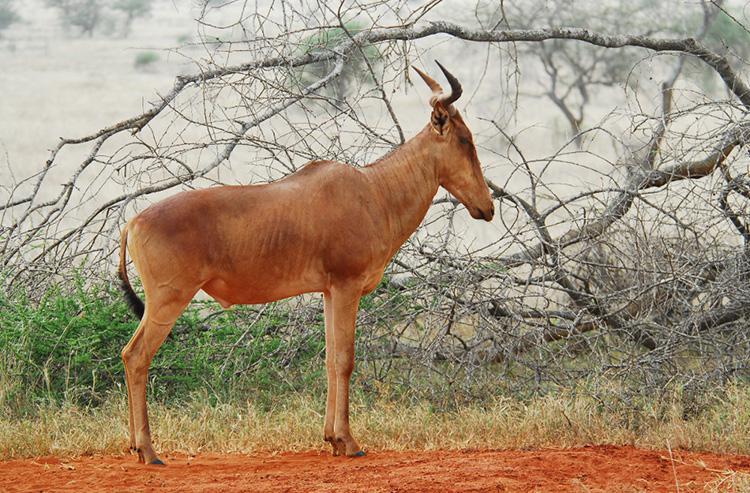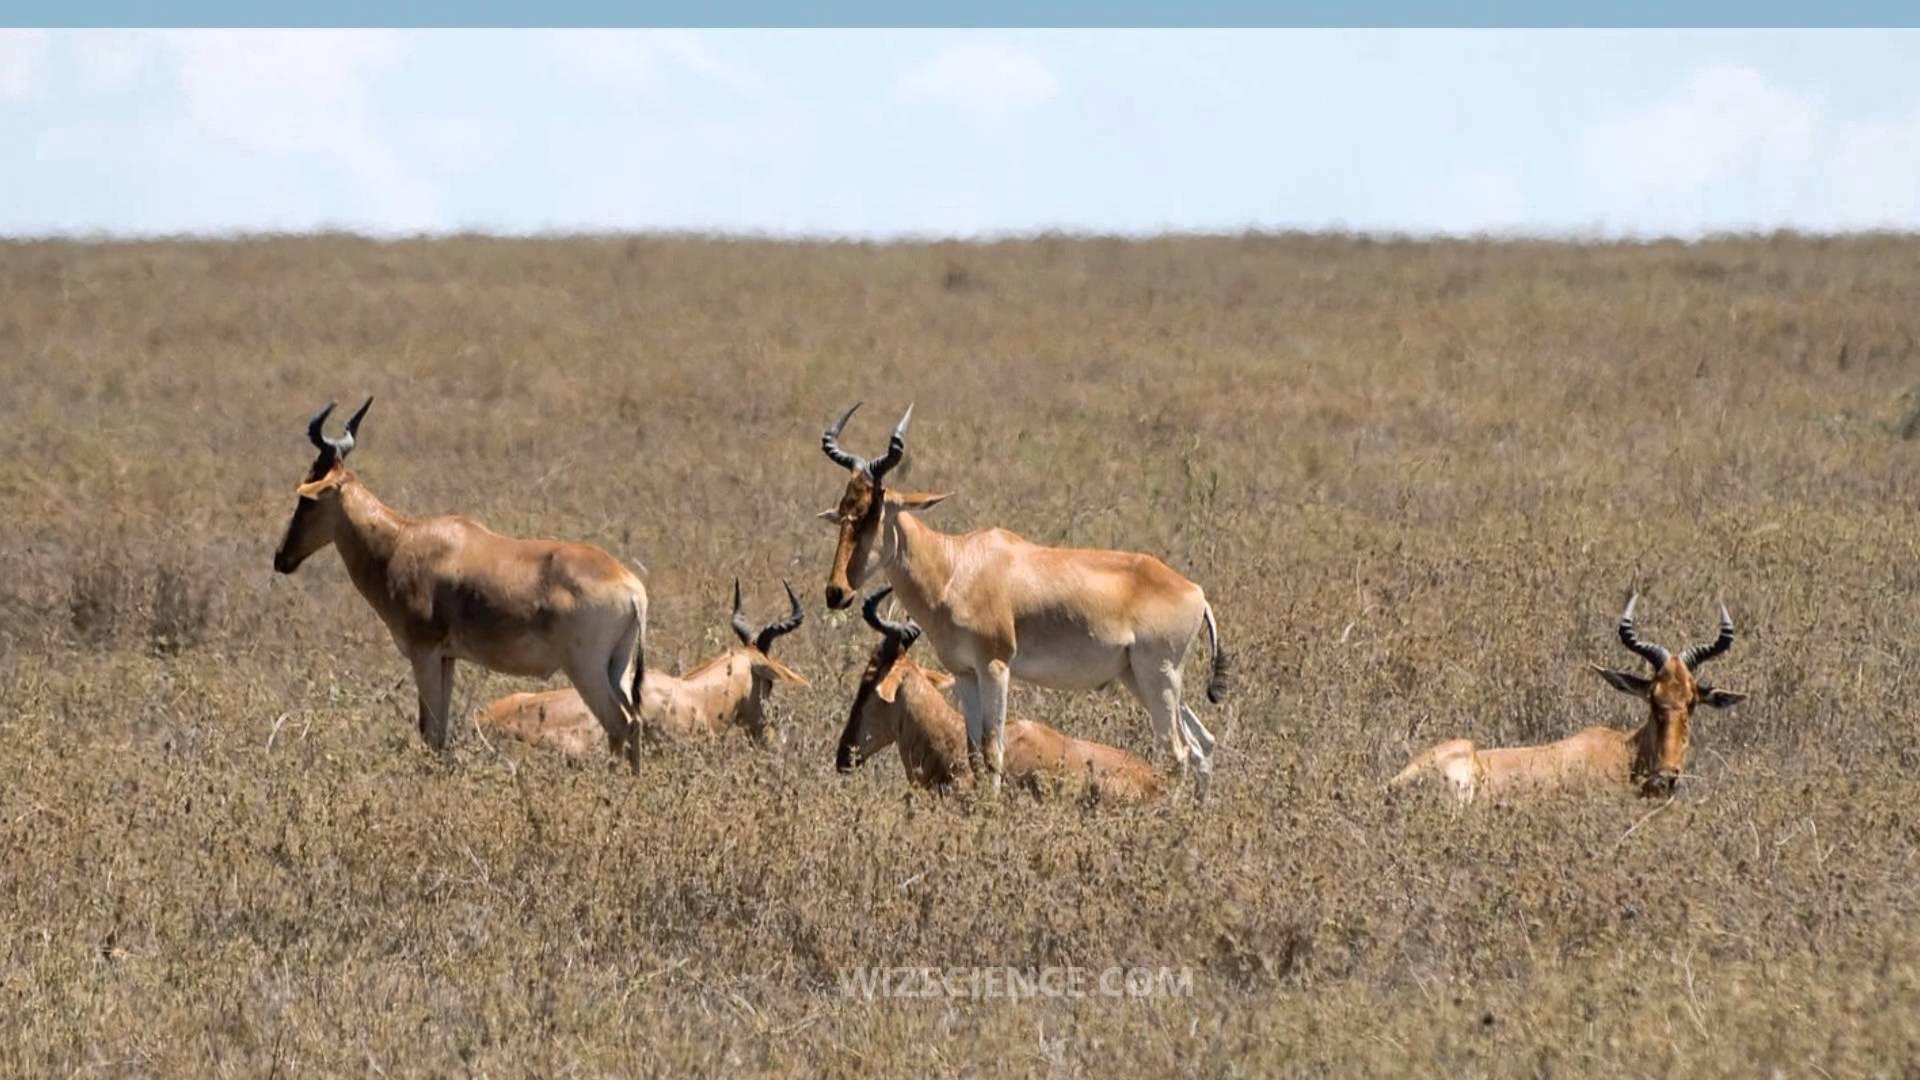The first image is the image on the left, the second image is the image on the right. Given the left and right images, does the statement "There are exactly two animals." hold true? Answer yes or no. No. The first image is the image on the left, the second image is the image on the right. Given the left and right images, does the statement "There are at most 2 animals in the image pair" hold true? Answer yes or no. No. 